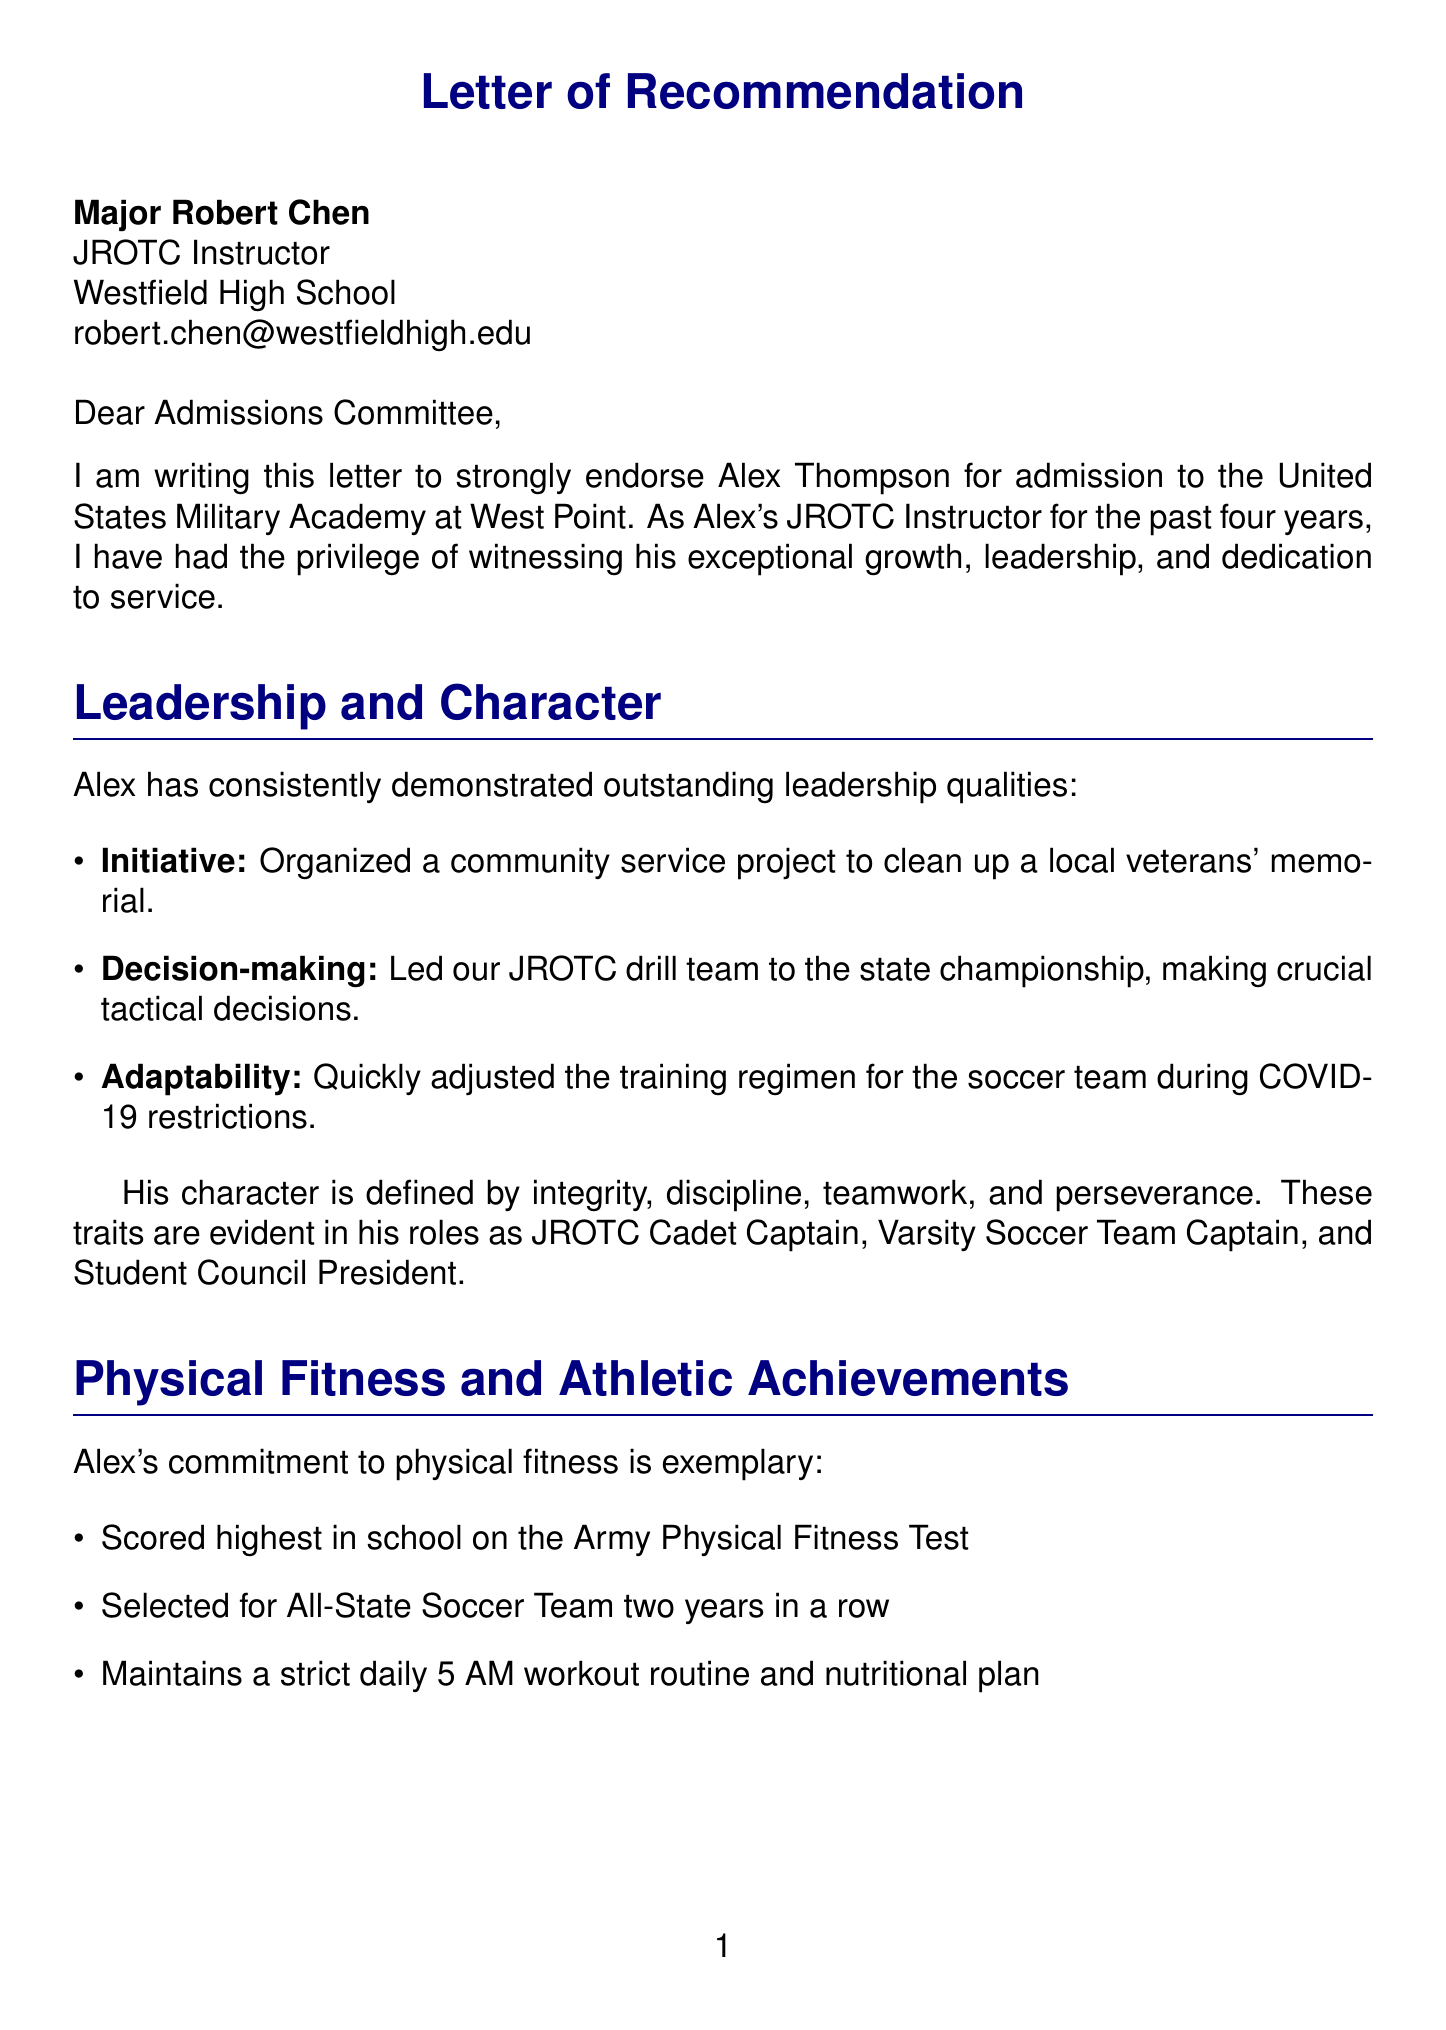What is the applicant's name? The applicant's name is mentioned at the beginning of the letter as Alex Thompson.
Answer: Alex Thompson Who wrote the letter of recommendation? The letter states that Major Robert Chen is the recommender and JROTC Instructor.
Answer: Major Robert Chen What is the applicant's current GPA? The document specifies that the applicant has a GPA of 3.9.
Answer: 3.9 Which military academy is Alex applying to? The letter indicates that Alex is applying to the United States Military Academy at West Point.
Answer: United States Military Academy at West Point What leadership position does Alex hold in JROTC? The document mentions that Alex is the JROTC Cadet Captain.
Answer: JROTC Cadet Captain What physical fitness achievement does Alex hold? The document states that Alex scored the highest in school on the Army Physical Fitness Test.
Answer: Scored highest in school on Army Physical Fitness Test What character traits are associated with the applicant? The document lists integrity, discipline, teamwork, and perseverance as character traits of the applicant.
Answer: Integrity, Discipline, Teamwork, Perseverance What is one of Alex's community involvement activities? The document mentions several activities, one being a volunteer firefighter trainee.
Answer: Volunteer firefighter trainee Which course is NOT listed as a relevant course in the document? The document lists AP Physics, AP Calculus, and Military History. A course like biology is not mentioned.
Answer: Biology What is Alex's goal related to his military career? The letter states that Alex aspires to serve as an officer in the U.S. Army Engineering Corps.
Answer: Officer in the U.S. Army Engineering Corps 